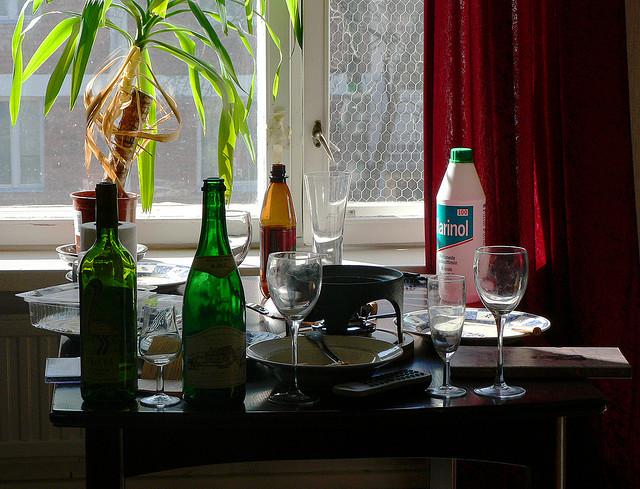What is in the glass?
Answer briefly. Nothing. What season was this photo taken?
Give a very brief answer. Spring. Could this be a train station?
Short answer required. No. How many glasses are set?
Write a very short answer. 4. How many glasses are there?
Quick response, please. 5. Is this table set for breakfast?
Give a very brief answer. No. What color are the curtains?
Concise answer only. Red. How many bottles are there?
Answer briefly. 4. 